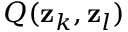Convert formula to latex. <formula><loc_0><loc_0><loc_500><loc_500>Q ( z _ { k } , z _ { l } )</formula> 